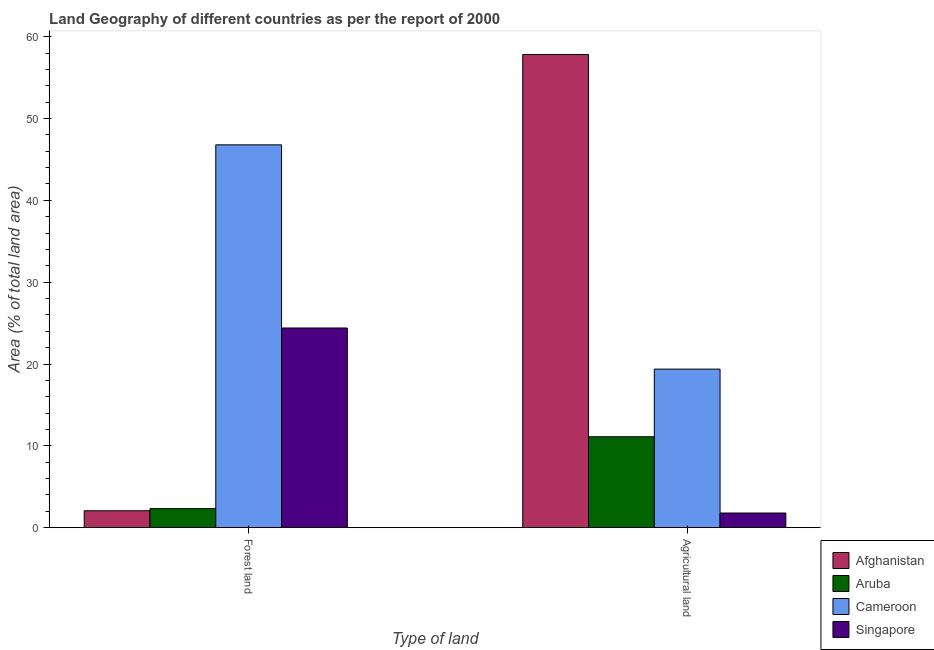How many bars are there on the 2nd tick from the left?
Your response must be concise. 4. What is the label of the 2nd group of bars from the left?
Your answer should be very brief. Agricultural land. What is the percentage of land area under agriculture in Singapore?
Offer a terse response. 1.79. Across all countries, what is the maximum percentage of land area under agriculture?
Keep it short and to the point. 57.83. Across all countries, what is the minimum percentage of land area under agriculture?
Your response must be concise. 1.79. In which country was the percentage of land area under forests maximum?
Provide a succinct answer. Cameroon. In which country was the percentage of land area under agriculture minimum?
Make the answer very short. Singapore. What is the total percentage of land area under agriculture in the graph?
Offer a very short reply. 90.11. What is the difference between the percentage of land area under forests in Singapore and that in Aruba?
Provide a short and direct response. 22.07. What is the difference between the percentage of land area under agriculture in Aruba and the percentage of land area under forests in Cameroon?
Make the answer very short. -35.67. What is the average percentage of land area under forests per country?
Make the answer very short. 18.9. What is the difference between the percentage of land area under agriculture and percentage of land area under forests in Afghanistan?
Provide a short and direct response. 55.76. What is the ratio of the percentage of land area under agriculture in Aruba to that in Cameroon?
Make the answer very short. 0.57. What does the 1st bar from the left in Agricultural land represents?
Make the answer very short. Afghanistan. What does the 3rd bar from the right in Agricultural land represents?
Offer a terse response. Aruba. How many countries are there in the graph?
Offer a very short reply. 4. Does the graph contain grids?
Offer a terse response. No. How are the legend labels stacked?
Your answer should be very brief. Vertical. What is the title of the graph?
Offer a terse response. Land Geography of different countries as per the report of 2000. What is the label or title of the X-axis?
Your response must be concise. Type of land. What is the label or title of the Y-axis?
Provide a short and direct response. Area (% of total land area). What is the Area (% of total land area) of Afghanistan in Forest land?
Your response must be concise. 2.07. What is the Area (% of total land area) of Aruba in Forest land?
Make the answer very short. 2.33. What is the Area (% of total land area) of Cameroon in Forest land?
Give a very brief answer. 46.79. What is the Area (% of total land area) in Singapore in Forest land?
Provide a succinct answer. 24.4. What is the Area (% of total land area) in Afghanistan in Agricultural land?
Offer a terse response. 57.83. What is the Area (% of total land area) of Aruba in Agricultural land?
Give a very brief answer. 11.11. What is the Area (% of total land area) in Cameroon in Agricultural land?
Give a very brief answer. 19.38. What is the Area (% of total land area) in Singapore in Agricultural land?
Provide a short and direct response. 1.79. Across all Type of land, what is the maximum Area (% of total land area) of Afghanistan?
Ensure brevity in your answer.  57.83. Across all Type of land, what is the maximum Area (% of total land area) in Aruba?
Keep it short and to the point. 11.11. Across all Type of land, what is the maximum Area (% of total land area) in Cameroon?
Offer a terse response. 46.79. Across all Type of land, what is the maximum Area (% of total land area) in Singapore?
Make the answer very short. 24.4. Across all Type of land, what is the minimum Area (% of total land area) in Afghanistan?
Offer a very short reply. 2.07. Across all Type of land, what is the minimum Area (% of total land area) in Aruba?
Give a very brief answer. 2.33. Across all Type of land, what is the minimum Area (% of total land area) in Cameroon?
Make the answer very short. 19.38. Across all Type of land, what is the minimum Area (% of total land area) of Singapore?
Keep it short and to the point. 1.79. What is the total Area (% of total land area) in Afghanistan in the graph?
Keep it short and to the point. 59.89. What is the total Area (% of total land area) of Aruba in the graph?
Keep it short and to the point. 13.44. What is the total Area (% of total land area) in Cameroon in the graph?
Provide a succinct answer. 66.16. What is the total Area (% of total land area) in Singapore in the graph?
Offer a terse response. 26.19. What is the difference between the Area (% of total land area) in Afghanistan in Forest land and that in Agricultural land?
Keep it short and to the point. -55.76. What is the difference between the Area (% of total land area) of Aruba in Forest land and that in Agricultural land?
Provide a short and direct response. -8.78. What is the difference between the Area (% of total land area) of Cameroon in Forest land and that in Agricultural land?
Give a very brief answer. 27.41. What is the difference between the Area (% of total land area) in Singapore in Forest land and that in Agricultural land?
Your answer should be compact. 22.61. What is the difference between the Area (% of total land area) of Afghanistan in Forest land and the Area (% of total land area) of Aruba in Agricultural land?
Give a very brief answer. -9.04. What is the difference between the Area (% of total land area) in Afghanistan in Forest land and the Area (% of total land area) in Cameroon in Agricultural land?
Provide a short and direct response. -17.31. What is the difference between the Area (% of total land area) in Afghanistan in Forest land and the Area (% of total land area) in Singapore in Agricultural land?
Offer a very short reply. 0.28. What is the difference between the Area (% of total land area) in Aruba in Forest land and the Area (% of total land area) in Cameroon in Agricultural land?
Give a very brief answer. -17.04. What is the difference between the Area (% of total land area) in Aruba in Forest land and the Area (% of total land area) in Singapore in Agricultural land?
Provide a short and direct response. 0.54. What is the difference between the Area (% of total land area) in Cameroon in Forest land and the Area (% of total land area) in Singapore in Agricultural land?
Keep it short and to the point. 44.99. What is the average Area (% of total land area) in Afghanistan per Type of land?
Make the answer very short. 29.95. What is the average Area (% of total land area) in Aruba per Type of land?
Provide a succinct answer. 6.72. What is the average Area (% of total land area) of Cameroon per Type of land?
Give a very brief answer. 33.08. What is the average Area (% of total land area) of Singapore per Type of land?
Your answer should be compact. 13.1. What is the difference between the Area (% of total land area) in Afghanistan and Area (% of total land area) in Aruba in Forest land?
Give a very brief answer. -0.27. What is the difference between the Area (% of total land area) in Afghanistan and Area (% of total land area) in Cameroon in Forest land?
Provide a succinct answer. -44.72. What is the difference between the Area (% of total land area) of Afghanistan and Area (% of total land area) of Singapore in Forest land?
Ensure brevity in your answer.  -22.34. What is the difference between the Area (% of total land area) of Aruba and Area (% of total land area) of Cameroon in Forest land?
Give a very brief answer. -44.45. What is the difference between the Area (% of total land area) in Aruba and Area (% of total land area) in Singapore in Forest land?
Your response must be concise. -22.07. What is the difference between the Area (% of total land area) of Cameroon and Area (% of total land area) of Singapore in Forest land?
Give a very brief answer. 22.38. What is the difference between the Area (% of total land area) of Afghanistan and Area (% of total land area) of Aruba in Agricultural land?
Provide a succinct answer. 46.72. What is the difference between the Area (% of total land area) of Afghanistan and Area (% of total land area) of Cameroon in Agricultural land?
Provide a succinct answer. 38.45. What is the difference between the Area (% of total land area) of Afghanistan and Area (% of total land area) of Singapore in Agricultural land?
Your answer should be compact. 56.04. What is the difference between the Area (% of total land area) in Aruba and Area (% of total land area) in Cameroon in Agricultural land?
Offer a terse response. -8.27. What is the difference between the Area (% of total land area) in Aruba and Area (% of total land area) in Singapore in Agricultural land?
Keep it short and to the point. 9.32. What is the difference between the Area (% of total land area) in Cameroon and Area (% of total land area) in Singapore in Agricultural land?
Ensure brevity in your answer.  17.59. What is the ratio of the Area (% of total land area) in Afghanistan in Forest land to that in Agricultural land?
Keep it short and to the point. 0.04. What is the ratio of the Area (% of total land area) in Aruba in Forest land to that in Agricultural land?
Make the answer very short. 0.21. What is the ratio of the Area (% of total land area) in Cameroon in Forest land to that in Agricultural land?
Your answer should be very brief. 2.41. What is the ratio of the Area (% of total land area) in Singapore in Forest land to that in Agricultural land?
Your answer should be very brief. 13.62. What is the difference between the highest and the second highest Area (% of total land area) of Afghanistan?
Your response must be concise. 55.76. What is the difference between the highest and the second highest Area (% of total land area) in Aruba?
Offer a terse response. 8.78. What is the difference between the highest and the second highest Area (% of total land area) in Cameroon?
Your response must be concise. 27.41. What is the difference between the highest and the second highest Area (% of total land area) in Singapore?
Your response must be concise. 22.61. What is the difference between the highest and the lowest Area (% of total land area) in Afghanistan?
Keep it short and to the point. 55.76. What is the difference between the highest and the lowest Area (% of total land area) in Aruba?
Ensure brevity in your answer.  8.78. What is the difference between the highest and the lowest Area (% of total land area) in Cameroon?
Make the answer very short. 27.41. What is the difference between the highest and the lowest Area (% of total land area) of Singapore?
Keep it short and to the point. 22.61. 